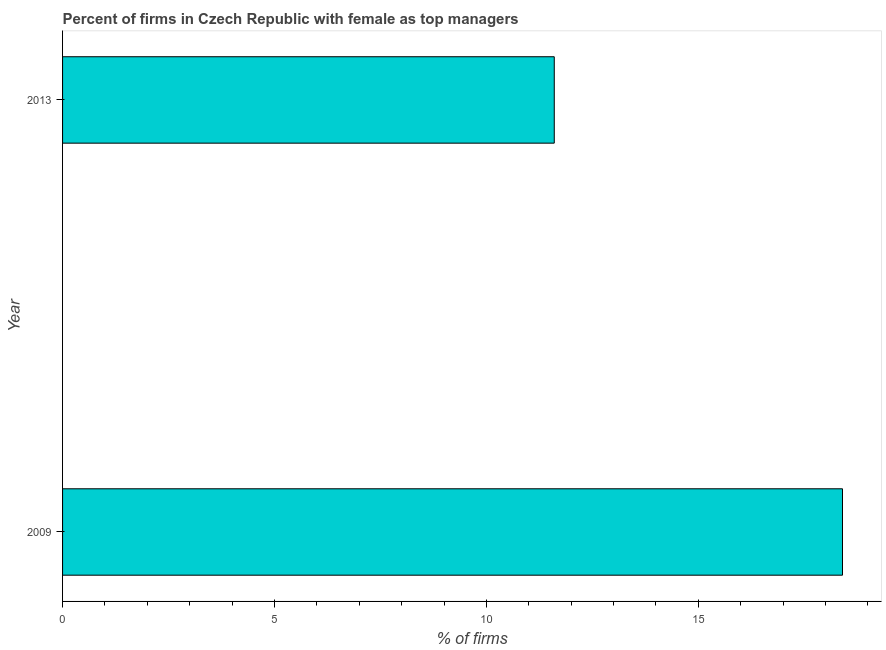Does the graph contain grids?
Your answer should be compact. No. What is the title of the graph?
Offer a terse response. Percent of firms in Czech Republic with female as top managers. What is the label or title of the X-axis?
Give a very brief answer. % of firms. What is the label or title of the Y-axis?
Ensure brevity in your answer.  Year. Across all years, what is the minimum percentage of firms with female as top manager?
Your answer should be compact. 11.6. In which year was the percentage of firms with female as top manager maximum?
Keep it short and to the point. 2009. In which year was the percentage of firms with female as top manager minimum?
Your answer should be very brief. 2013. What is the sum of the percentage of firms with female as top manager?
Your response must be concise. 30. What is the average percentage of firms with female as top manager per year?
Your response must be concise. 15. In how many years, is the percentage of firms with female as top manager greater than 7 %?
Offer a terse response. 2. What is the ratio of the percentage of firms with female as top manager in 2009 to that in 2013?
Provide a succinct answer. 1.59. Is the percentage of firms with female as top manager in 2009 less than that in 2013?
Keep it short and to the point. No. In how many years, is the percentage of firms with female as top manager greater than the average percentage of firms with female as top manager taken over all years?
Provide a short and direct response. 1. How many bars are there?
Your response must be concise. 2. Are all the bars in the graph horizontal?
Your answer should be very brief. Yes. What is the difference between two consecutive major ticks on the X-axis?
Offer a very short reply. 5. What is the ratio of the % of firms in 2009 to that in 2013?
Offer a terse response. 1.59. 